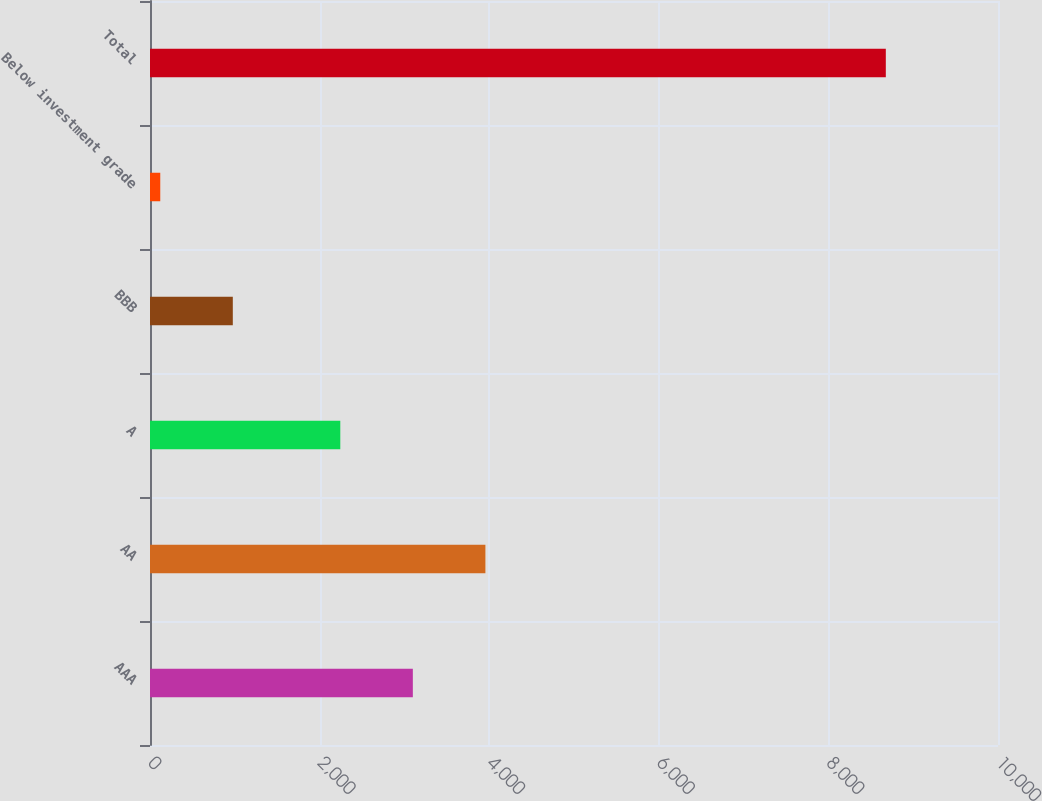Convert chart. <chart><loc_0><loc_0><loc_500><loc_500><bar_chart><fcel>AAA<fcel>AA<fcel>A<fcel>BBB<fcel>Below investment grade<fcel>Total<nl><fcel>3099.6<fcel>3955.2<fcel>2244<fcel>976.6<fcel>121<fcel>8677<nl></chart> 